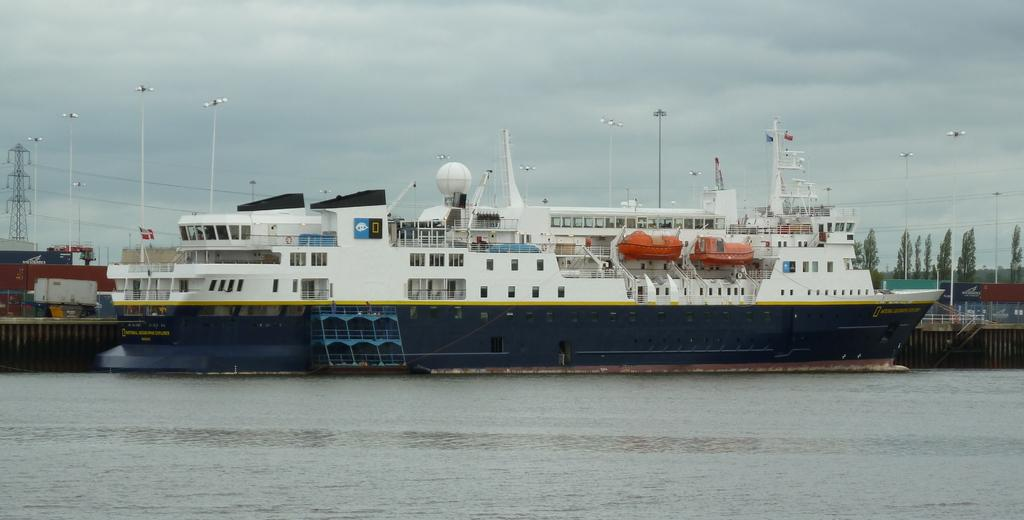What is the main subject in the foreground of the image? There is a ship in the water in the foreground. What can be seen in the background of the image? In the background, there is a fence, boats, trees, towers, and the sky. Can you describe the setting of the image? The image may have been taken at a lake, as there is water in the foreground and a variety of structures and natural elements in the background. What type of beam is holding up the church in the image? There is no church present in the image, so it is not possible to determine what type of beam might be holding it up. 